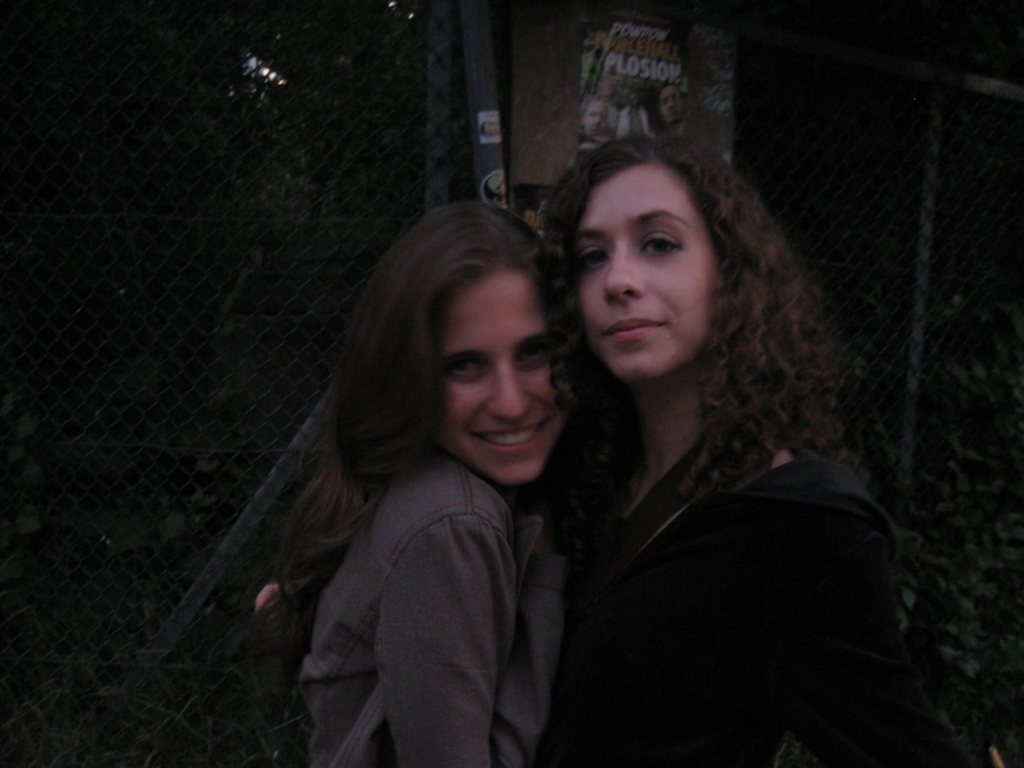Can you comment on the mood conveyed by the image? The image conveys a warm and personal mood, emphasized by the soft, natural lighting and the close pose of the subjects. Their smiles and the intimate proximity suggest a moment of connection and friendship. 